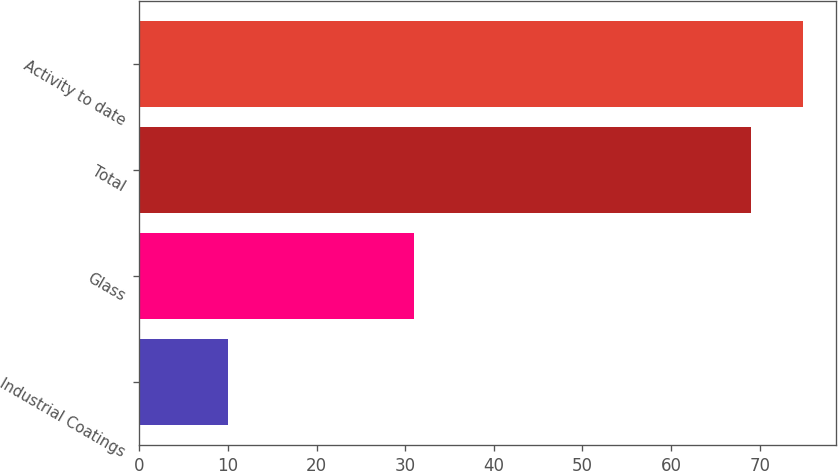Convert chart to OTSL. <chart><loc_0><loc_0><loc_500><loc_500><bar_chart><fcel>Industrial Coatings<fcel>Glass<fcel>Total<fcel>Activity to date<nl><fcel>10<fcel>31<fcel>69<fcel>74.9<nl></chart> 